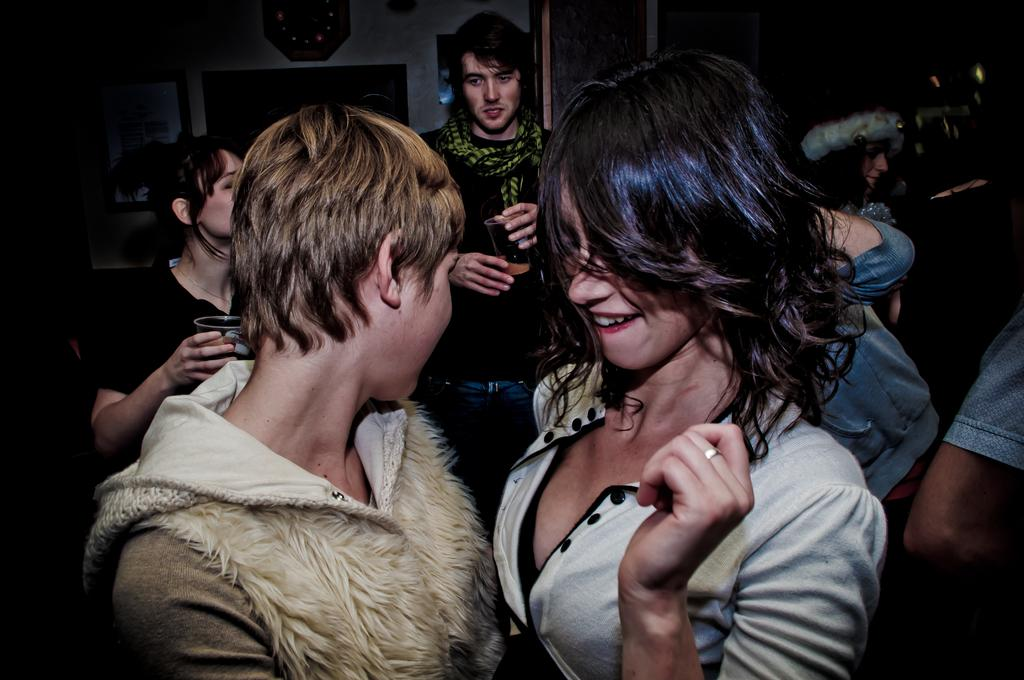Who is present in the image? There is a woman and another person in the image. Where are the woman and the other person located? They are in the middle of the image. What can be seen in the background of the image? In the background, there are two persons holding wine glasses. How are the two persons holding the wine glasses? They have their hands on the glasses. What is visible in the background of the image? There is a wall in the background of the image. What type of club is the woman holding in the image? There is no club present in the image. 